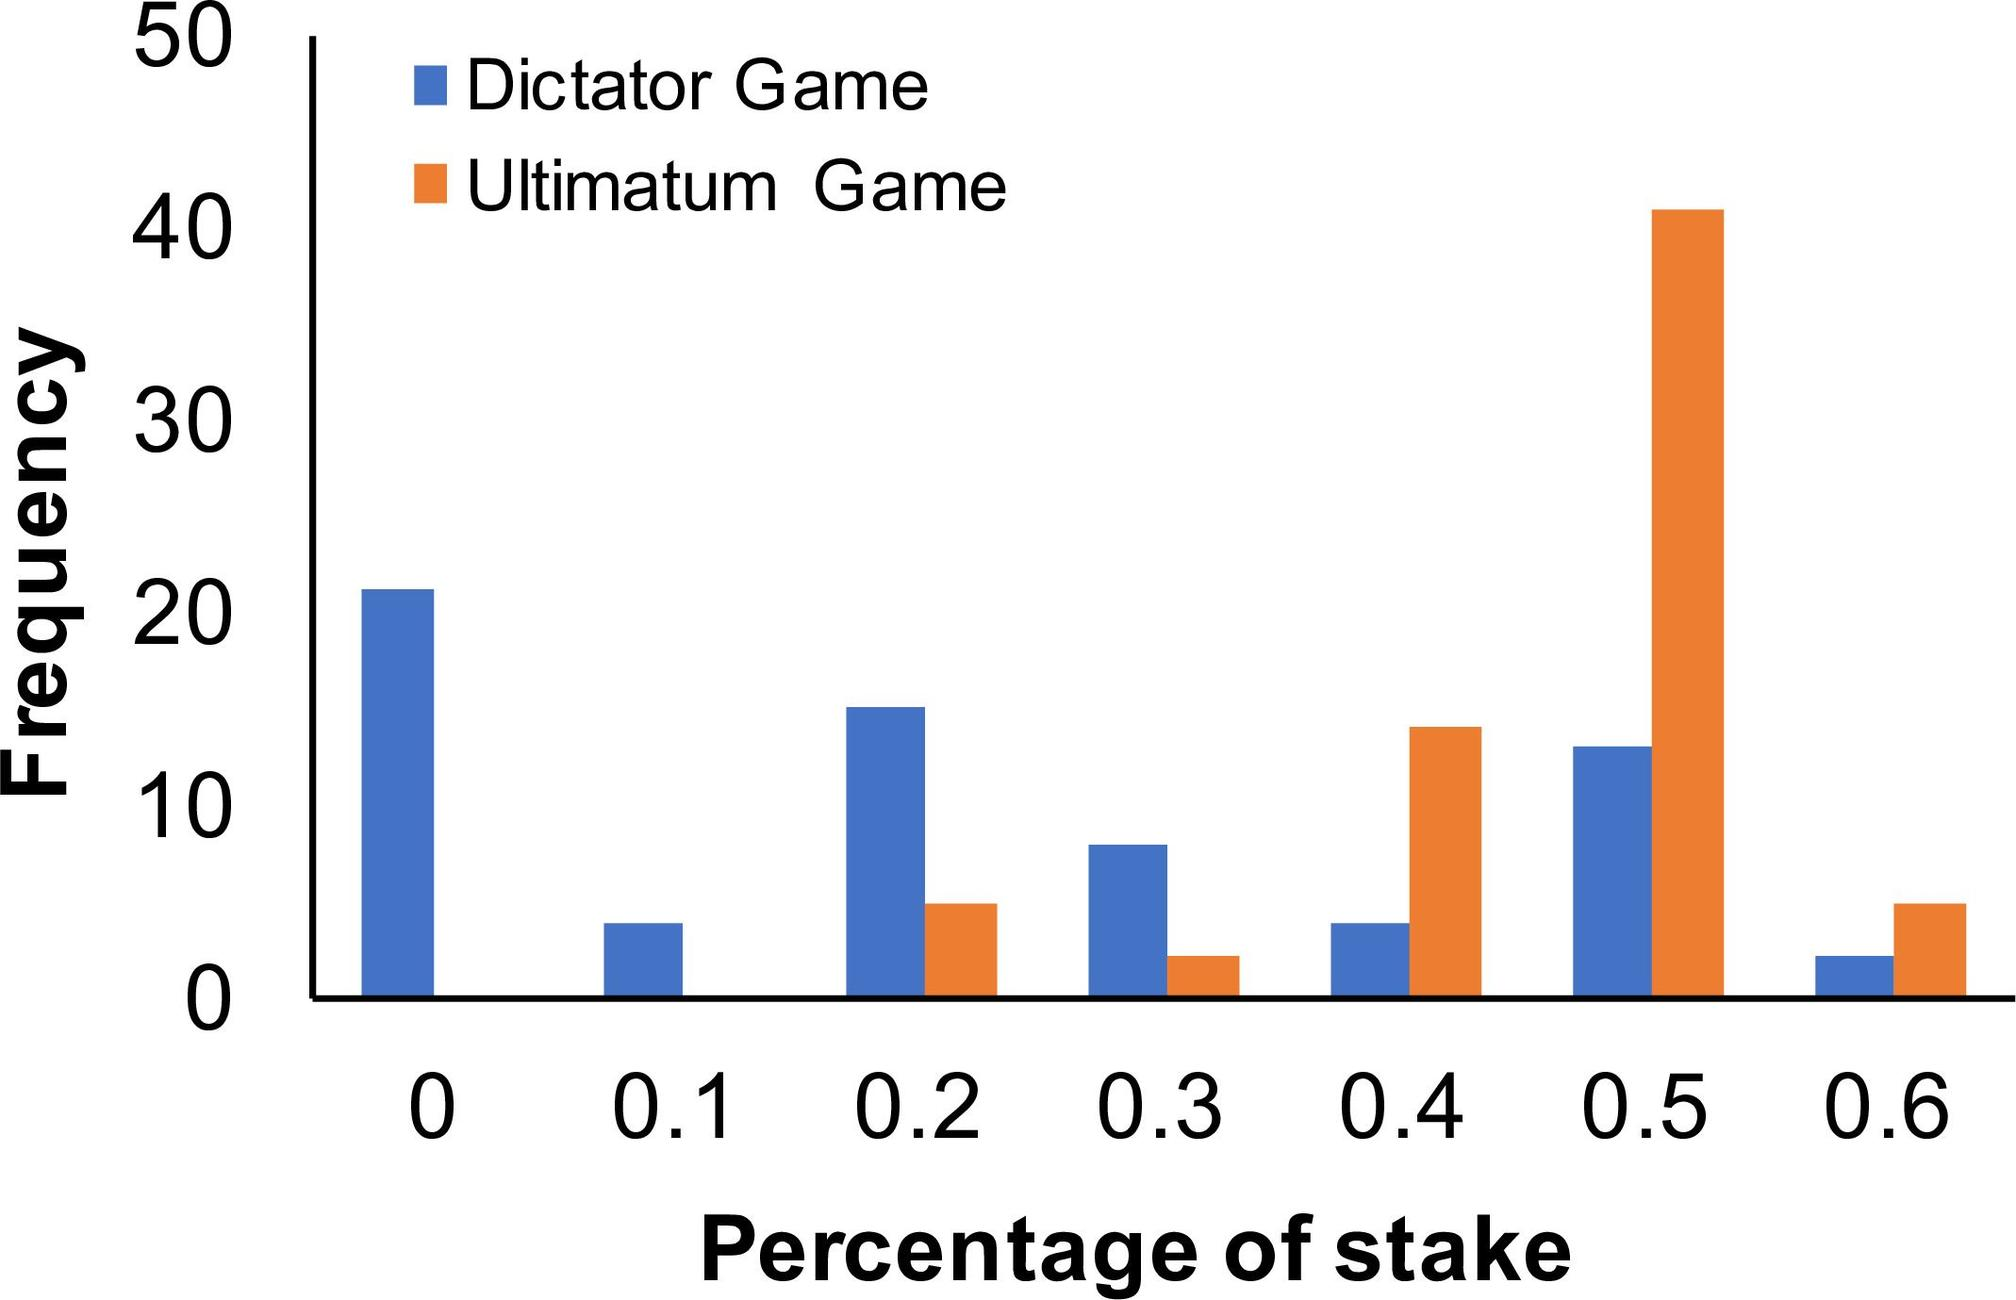Can you discuss the trend observed in offer frequencies as the stake percentage increases? The trend depicted in the bar graph shows an initial decrease in offer frequency for both games as the percentage of the stake increases from 0.1 to 0.3, followed by a sharp increase in the Ultimatum Game at the 0.5 stake level. The Dictator Game shows less variability across different stake levels, suggesting that proposers in the Dictator Game may not significantly adjust their offers in relation to the stake percentage. 